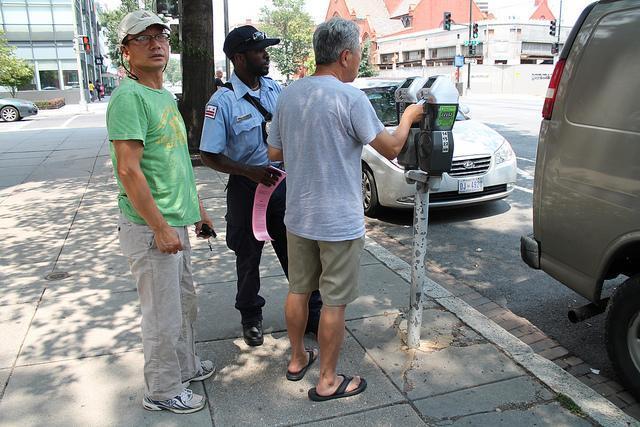How many people are wearing hats?
Give a very brief answer. 2. How many people are visible?
Give a very brief answer. 3. How many cars are in the photo?
Give a very brief answer. 2. 